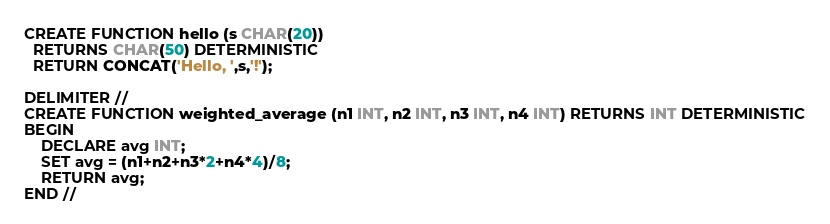<code> <loc_0><loc_0><loc_500><loc_500><_SQL_>CREATE FUNCTION hello (s CHAR(20))
  RETURNS CHAR(50) DETERMINISTIC
  RETURN CONCAT('Hello, ',s,'!');

DELIMITER //
CREATE FUNCTION weighted_average (n1 INT, n2 INT, n3 INT, n4 INT) RETURNS INT DETERMINISTIC
BEGIN
    DECLARE avg INT;
    SET avg = (n1+n2+n3*2+n4*4)/8;
    RETURN avg;
END //
</code> 